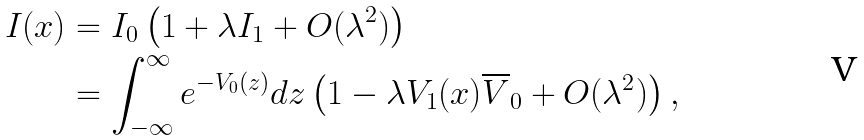Convert formula to latex. <formula><loc_0><loc_0><loc_500><loc_500>I ( x ) & = I _ { 0 } \left ( 1 + \lambda I _ { 1 } + O ( \lambda ^ { 2 } ) \right ) \\ & = \int _ { - \infty } ^ { \infty } e ^ { - V _ { 0 } ( z ) } d z \left ( 1 - \lambda V _ { 1 } ( x ) \overline { V } _ { 0 } + O ( \lambda ^ { 2 } ) \right ) ,</formula> 